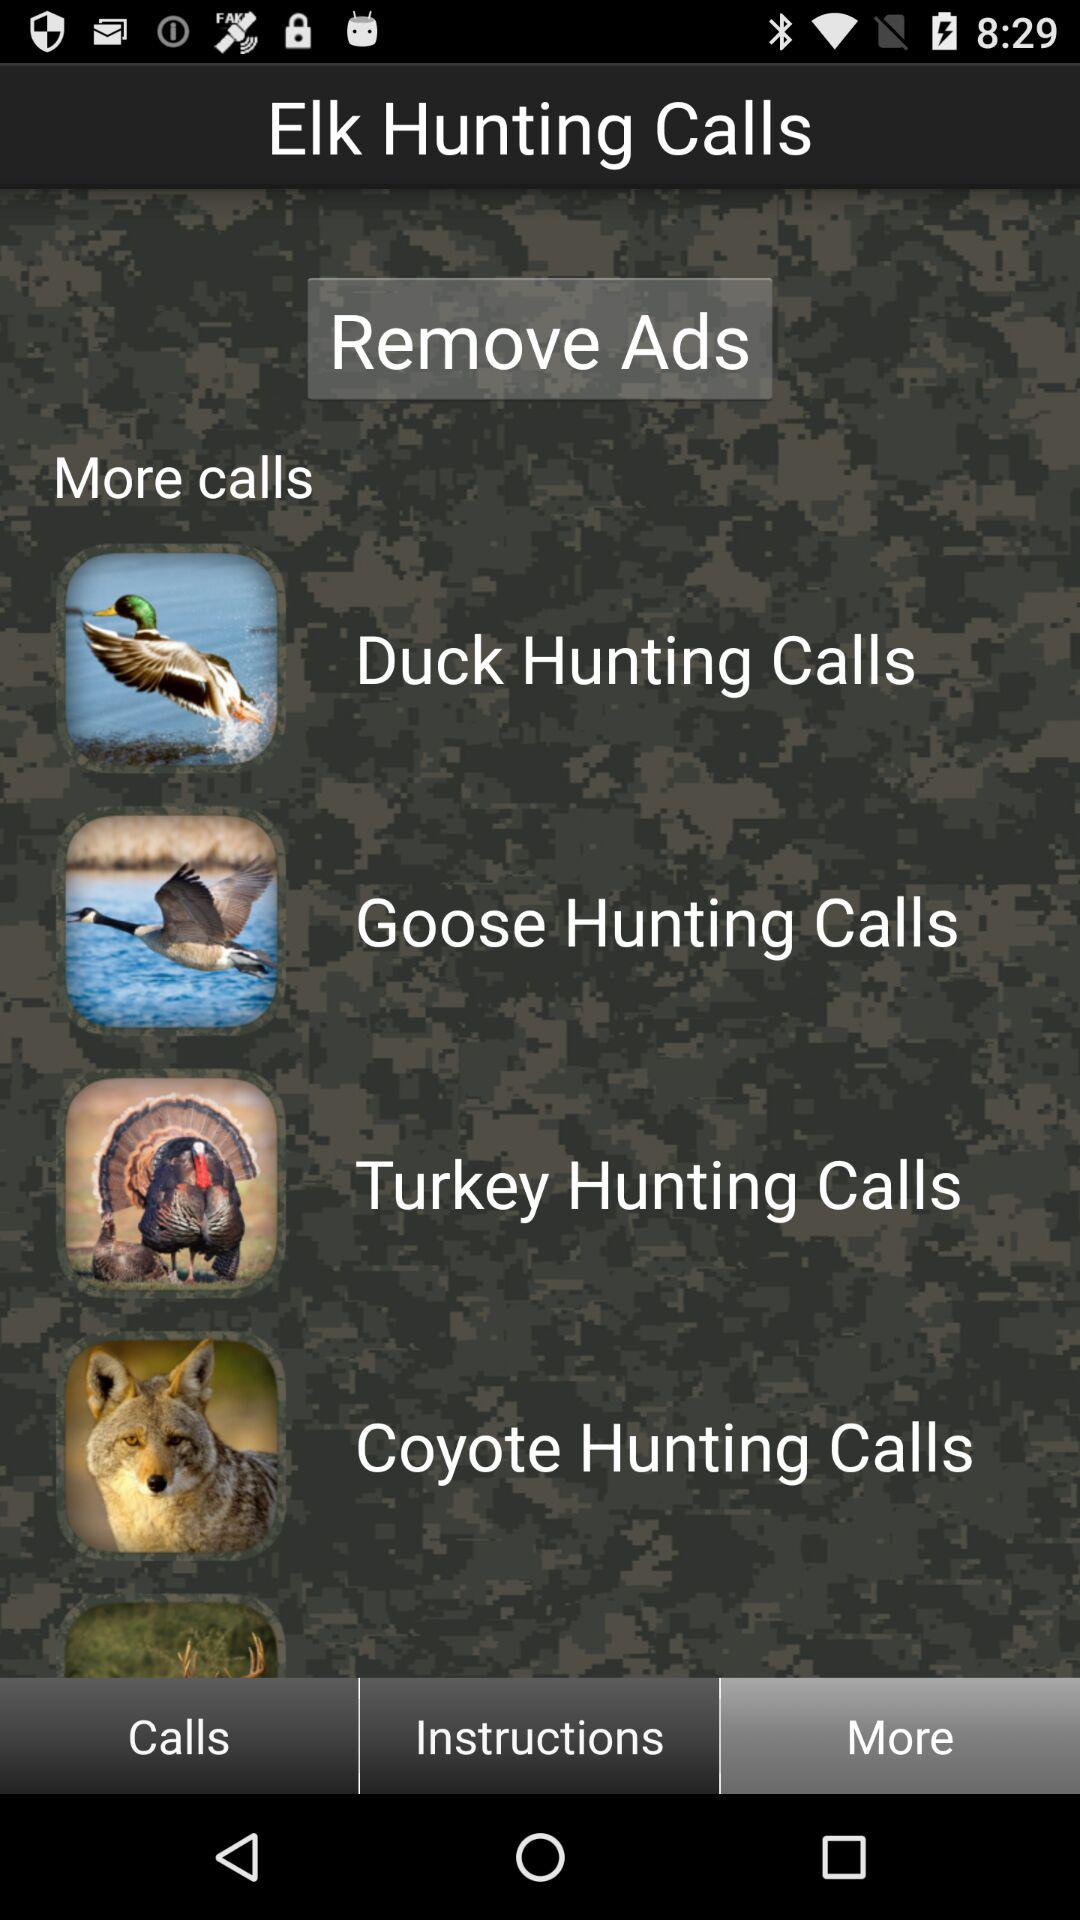How many calls are available for ducks, geese, and turkeys combined?
Answer the question using a single word or phrase. 3 